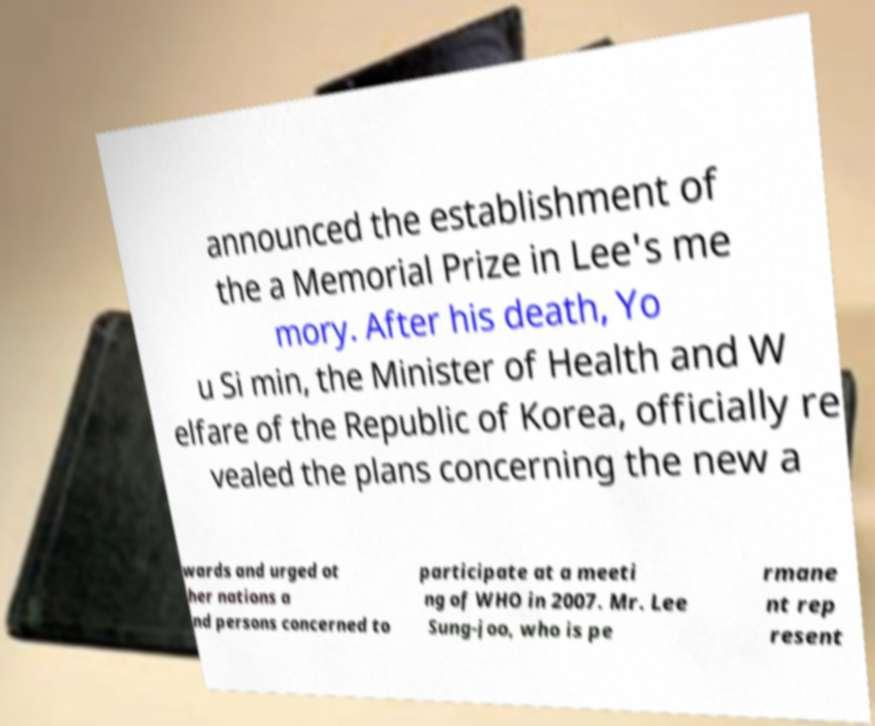What messages or text are displayed in this image? I need them in a readable, typed format. announced the establishment of the a Memorial Prize in Lee's me mory. After his death, Yo u Si min, the Minister of Health and W elfare of the Republic of Korea, officially re vealed the plans concerning the new a wards and urged ot her nations a nd persons concerned to participate at a meeti ng of WHO in 2007. Mr. Lee Sung-joo, who is pe rmane nt rep resent 